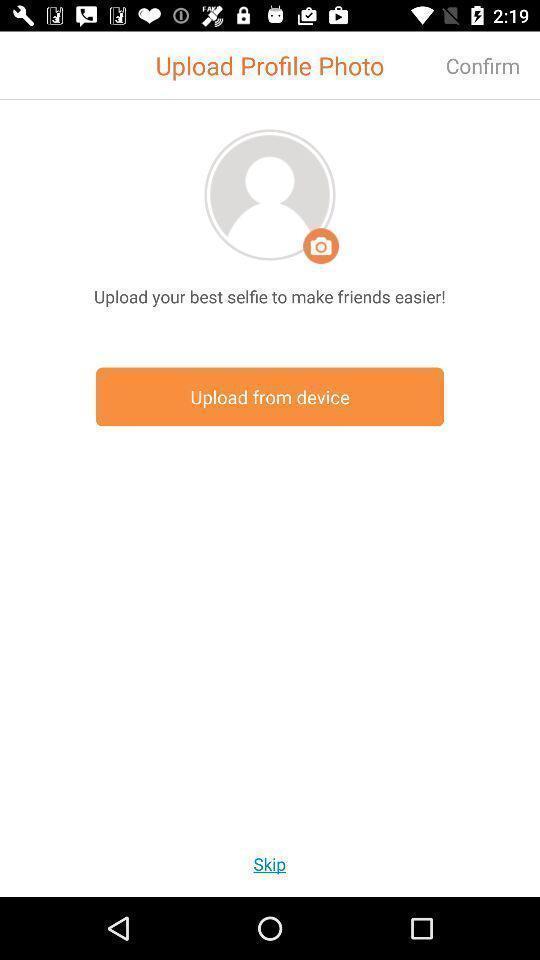Please provide a description for this image. Upload profile photo from device. 